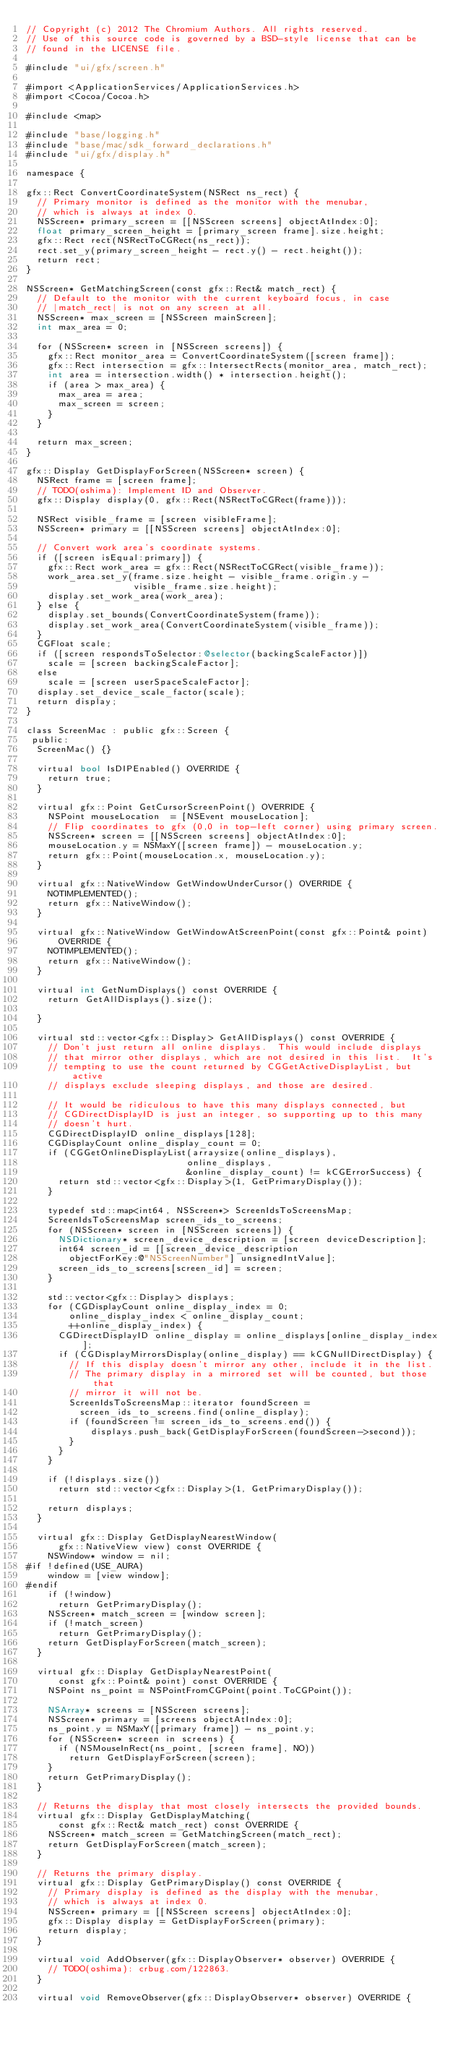Convert code to text. <code><loc_0><loc_0><loc_500><loc_500><_ObjectiveC_>// Copyright (c) 2012 The Chromium Authors. All rights reserved.
// Use of this source code is governed by a BSD-style license that can be
// found in the LICENSE file.

#include "ui/gfx/screen.h"

#import <ApplicationServices/ApplicationServices.h>
#import <Cocoa/Cocoa.h>

#include <map>

#include "base/logging.h"
#include "base/mac/sdk_forward_declarations.h"
#include "ui/gfx/display.h"

namespace {

gfx::Rect ConvertCoordinateSystem(NSRect ns_rect) {
  // Primary monitor is defined as the monitor with the menubar,
  // which is always at index 0.
  NSScreen* primary_screen = [[NSScreen screens] objectAtIndex:0];
  float primary_screen_height = [primary_screen frame].size.height;
  gfx::Rect rect(NSRectToCGRect(ns_rect));
  rect.set_y(primary_screen_height - rect.y() - rect.height());
  return rect;
}

NSScreen* GetMatchingScreen(const gfx::Rect& match_rect) {
  // Default to the monitor with the current keyboard focus, in case
  // |match_rect| is not on any screen at all.
  NSScreen* max_screen = [NSScreen mainScreen];
  int max_area = 0;

  for (NSScreen* screen in [NSScreen screens]) {
    gfx::Rect monitor_area = ConvertCoordinateSystem([screen frame]);
    gfx::Rect intersection = gfx::IntersectRects(monitor_area, match_rect);
    int area = intersection.width() * intersection.height();
    if (area > max_area) {
      max_area = area;
      max_screen = screen;
    }
  }

  return max_screen;
}

gfx::Display GetDisplayForScreen(NSScreen* screen) {
  NSRect frame = [screen frame];
  // TODO(oshima): Implement ID and Observer.
  gfx::Display display(0, gfx::Rect(NSRectToCGRect(frame)));

  NSRect visible_frame = [screen visibleFrame];
  NSScreen* primary = [[NSScreen screens] objectAtIndex:0];

  // Convert work area's coordinate systems.
  if ([screen isEqual:primary]) {
    gfx::Rect work_area = gfx::Rect(NSRectToCGRect(visible_frame));
    work_area.set_y(frame.size.height - visible_frame.origin.y -
                    visible_frame.size.height);
    display.set_work_area(work_area);
  } else {
    display.set_bounds(ConvertCoordinateSystem(frame));
    display.set_work_area(ConvertCoordinateSystem(visible_frame));
  }
  CGFloat scale;
  if ([screen respondsToSelector:@selector(backingScaleFactor)])
    scale = [screen backingScaleFactor];
  else
    scale = [screen userSpaceScaleFactor];
  display.set_device_scale_factor(scale);
  return display;
}

class ScreenMac : public gfx::Screen {
 public:
  ScreenMac() {}

  virtual bool IsDIPEnabled() OVERRIDE {
    return true;
  }

  virtual gfx::Point GetCursorScreenPoint() OVERRIDE {
    NSPoint mouseLocation  = [NSEvent mouseLocation];
    // Flip coordinates to gfx (0,0 in top-left corner) using primary screen.
    NSScreen* screen = [[NSScreen screens] objectAtIndex:0];
    mouseLocation.y = NSMaxY([screen frame]) - mouseLocation.y;
    return gfx::Point(mouseLocation.x, mouseLocation.y);
  }

  virtual gfx::NativeWindow GetWindowUnderCursor() OVERRIDE {
    NOTIMPLEMENTED();
    return gfx::NativeWindow();
  }

  virtual gfx::NativeWindow GetWindowAtScreenPoint(const gfx::Point& point)
      OVERRIDE {
    NOTIMPLEMENTED();
    return gfx::NativeWindow();
  }

  virtual int GetNumDisplays() const OVERRIDE {
    return GetAllDisplays().size();

  }

  virtual std::vector<gfx::Display> GetAllDisplays() const OVERRIDE {
    // Don't just return all online displays.  This would include displays
    // that mirror other displays, which are not desired in this list.  It's
    // tempting to use the count returned by CGGetActiveDisplayList, but active
    // displays exclude sleeping displays, and those are desired.

    // It would be ridiculous to have this many displays connected, but
    // CGDirectDisplayID is just an integer, so supporting up to this many
    // doesn't hurt.
    CGDirectDisplayID online_displays[128];
    CGDisplayCount online_display_count = 0;
    if (CGGetOnlineDisplayList(arraysize(online_displays),
                              online_displays,
                              &online_display_count) != kCGErrorSuccess) {
      return std::vector<gfx::Display>(1, GetPrimaryDisplay());
    }

    typedef std::map<int64, NSScreen*> ScreenIdsToScreensMap;
    ScreenIdsToScreensMap screen_ids_to_screens;
    for (NSScreen* screen in [NSScreen screens]) {
      NSDictionary* screen_device_description = [screen deviceDescription];
      int64 screen_id = [[screen_device_description
        objectForKey:@"NSScreenNumber"] unsignedIntValue];
      screen_ids_to_screens[screen_id] = screen;
    }

    std::vector<gfx::Display> displays;
    for (CGDisplayCount online_display_index = 0;
        online_display_index < online_display_count;
        ++online_display_index) {
      CGDirectDisplayID online_display = online_displays[online_display_index];
      if (CGDisplayMirrorsDisplay(online_display) == kCGNullDirectDisplay) {
        // If this display doesn't mirror any other, include it in the list.
        // The primary display in a mirrored set will be counted, but those that
        // mirror it will not be.
        ScreenIdsToScreensMap::iterator foundScreen =
          screen_ids_to_screens.find(online_display);
        if (foundScreen != screen_ids_to_screens.end()) {
            displays.push_back(GetDisplayForScreen(foundScreen->second));
        }
      }
    }

    if (!displays.size())
      return std::vector<gfx::Display>(1, GetPrimaryDisplay());

    return displays;
  }

  virtual gfx::Display GetDisplayNearestWindow(
      gfx::NativeView view) const OVERRIDE {
    NSWindow* window = nil;
#if !defined(USE_AURA)
    window = [view window];
#endif
    if (!window)
      return GetPrimaryDisplay();
    NSScreen* match_screen = [window screen];
    if (!match_screen)
      return GetPrimaryDisplay();
    return GetDisplayForScreen(match_screen);
  }

  virtual gfx::Display GetDisplayNearestPoint(
      const gfx::Point& point) const OVERRIDE {
    NSPoint ns_point = NSPointFromCGPoint(point.ToCGPoint());

    NSArray* screens = [NSScreen screens];
    NSScreen* primary = [screens objectAtIndex:0];
    ns_point.y = NSMaxY([primary frame]) - ns_point.y;
    for (NSScreen* screen in screens) {
      if (NSMouseInRect(ns_point, [screen frame], NO))
        return GetDisplayForScreen(screen);
    }
    return GetPrimaryDisplay();
  }

  // Returns the display that most closely intersects the provided bounds.
  virtual gfx::Display GetDisplayMatching(
      const gfx::Rect& match_rect) const OVERRIDE {
    NSScreen* match_screen = GetMatchingScreen(match_rect);
    return GetDisplayForScreen(match_screen);
  }

  // Returns the primary display.
  virtual gfx::Display GetPrimaryDisplay() const OVERRIDE {
    // Primary display is defined as the display with the menubar,
    // which is always at index 0.
    NSScreen* primary = [[NSScreen screens] objectAtIndex:0];
    gfx::Display display = GetDisplayForScreen(primary);
    return display;
  }

  virtual void AddObserver(gfx::DisplayObserver* observer) OVERRIDE {
    // TODO(oshima): crbug.com/122863.
  }

  virtual void RemoveObserver(gfx::DisplayObserver* observer) OVERRIDE {</code> 